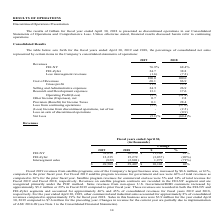From Frequency Electronics's financial document, What is the amount of revenue from FEI-NY in 2018 and 2019 respectively? The document shows two values: 26,936 and 38,096 (in thousands). From the document: "FEI-NY $ 38,096 $ 26,936 $ 11,160 41% FEI-NY $ 38,096 $ 26,936 $ 11,160 41%..." Also, What is the amount of revenue from FEI-Zyfer in 2018 and 2019 respectively? The document shows two values: 15,272 and 12,235 (in thousands). From the document: "FEI-Zyfer 12,235 15,272 (3,037 ) (20%) Intersegment sales (822) (2,801) 1,979 (71%) $ 49,509 $ 39,407 $ 10,102 26% FEI-Zyfer 12,235 15,272 (3,037 ) (2..." Also, How much did revenues from satellite programs change in 2019? increased by $8.6 million, or 61%, compared to the prior fiscal year.. The document states: "grams, one of the Company’s largest business area, increased by $8.6 million, or 61%, compared to the prior fiscal year. For Fiscal 2019 satellite pro..." Also, can you calculate: In fiscal year 2019, what is the percentage constitution of revenues from FEI-NY among the total revenue? Based on the calculation: 38,096/49,509, the result is 76.95 (percentage). This is based on the information: "%) Intersegment sales (822) (2,801) 1,979 (71%) $ 49,509 $ 39,407 $ 10,102 26% FEI-NY $ 38,096 $ 26,936 $ 11,160 41%..." The key data points involved are: 38,096, 49,509. Also, can you calculate: In fiscal year 2018, what is the percentage constitution of revenues from FEI-Zyfer among the total revenue? Based on the calculation: 15,272/39,407, the result is 38.75 (percentage). This is based on the information: "egment sales (822) (2,801) 1,979 (71%) $ 49,509 $ 39,407 $ 10,102 26% FEI-Zyfer 12,235 15,272 (3,037 ) (20%) Intersegment sales (822) (2,801) 1,979 (71%) $ 49,509 $ 39,407 $ 10,102 26%..." The key data points involved are: 15,272, 39,407. Also, can you calculate: What is the average total revenue for fiscal years 2018 and 2019? To answer this question, I need to perform calculations using the financial data. The calculation is: (49,509+39,407)/2, which equals 44458 (in thousands). This is based on the information: "%) Intersegment sales (822) (2,801) 1,979 (71%) $ 49,509 $ 39,407 $ 10,102 26% egment sales (822) (2,801) 1,979 (71%) $ 49,509 $ 39,407 $ 10,102 26%..." The key data points involved are: 39,407, 49,509. 